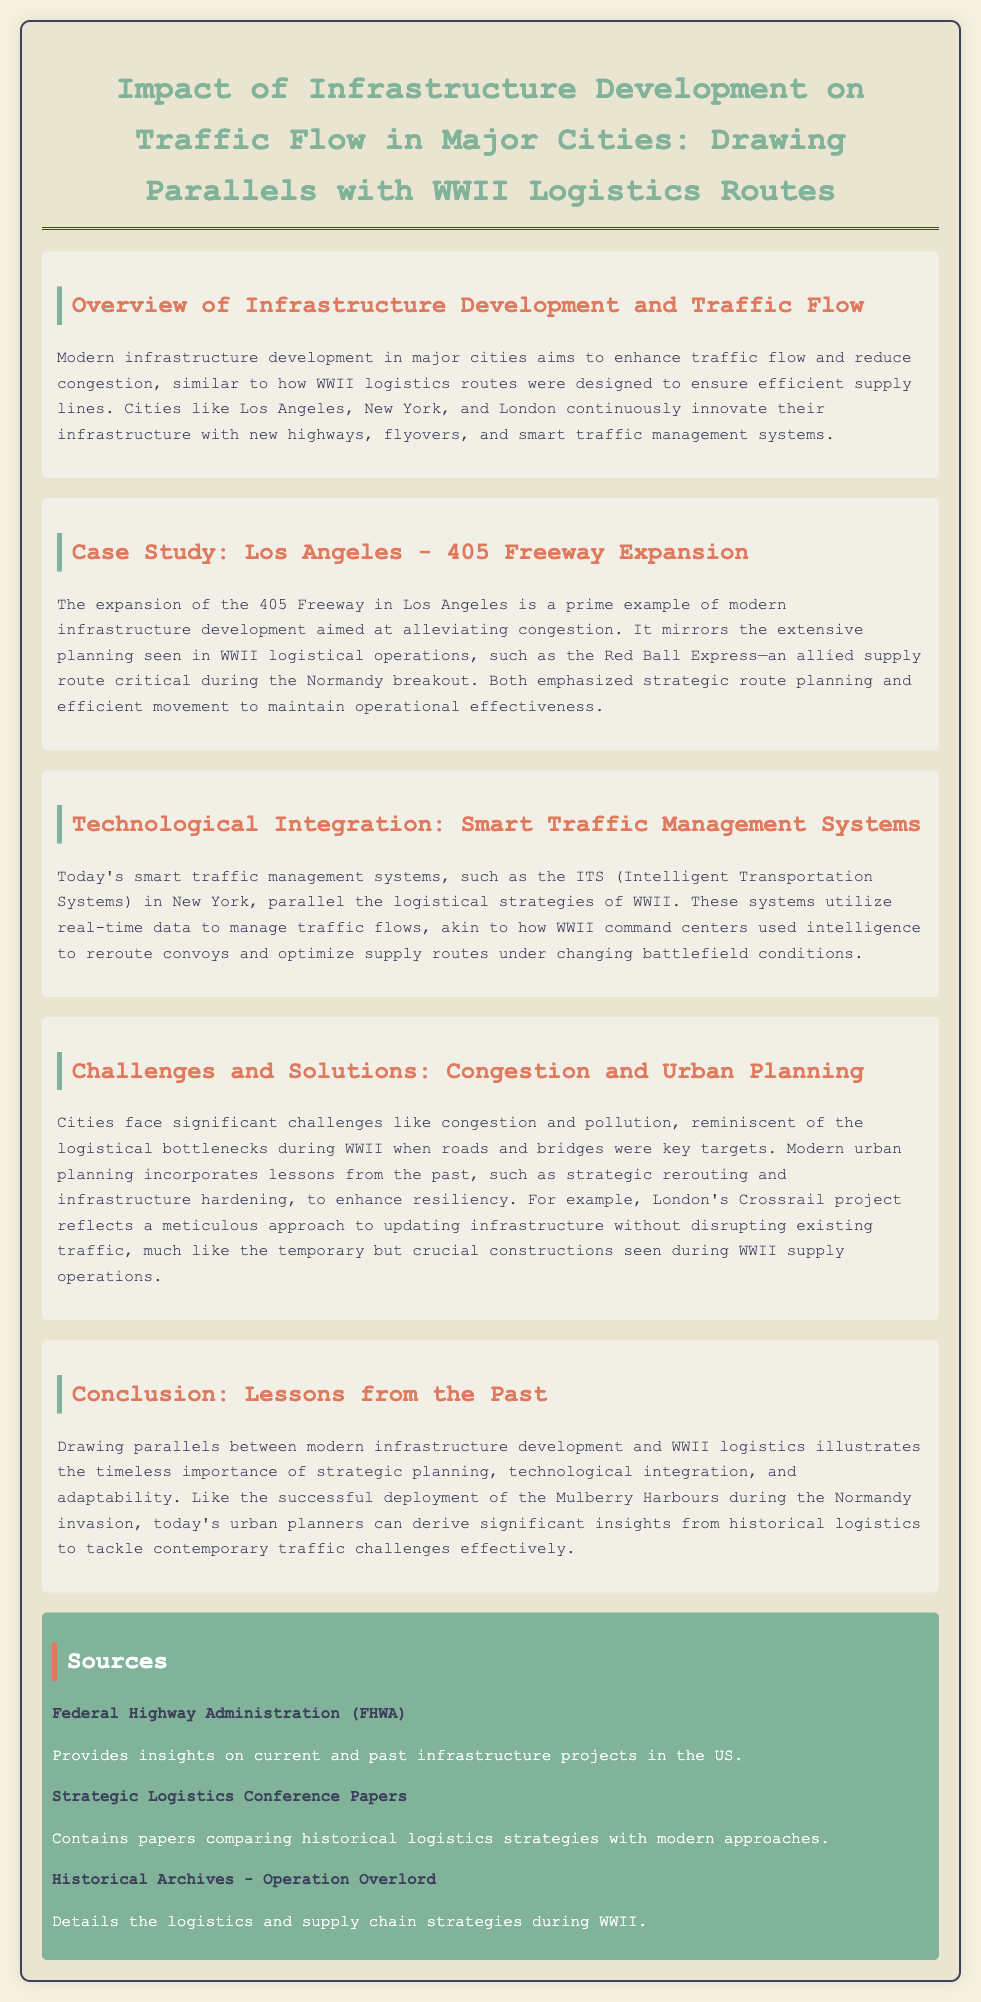What is the title of the report? The title of the report is presented at the top of the document, summarizing its focus on infrastructure and traffic flow.
Answer: Impact of Infrastructure Development on Traffic Flow in Major Cities: Drawing Parallels with WWII Logistics Routes Which city is highlighted for freeway expansion? The specific case study in the document points out a significant infrastructure project that took place in this city.
Answer: Los Angeles What does ITS stand for in the context of modern traffic systems? The abbreviation is provided in the section discussing smart traffic management systems, detailing its full form.
Answer: Intelligent Transportation Systems What historical operation is compared to the 405 Freeway expansion? The document mentions a specific logistic operation that serves as a parallel to infrastructure strategies implemented during WWII.
Answer: Red Ball Express What major construction project is referenced in London? An example is provided to illustrate modern urban planning efforts and its comparison to historical logistics strategies during WWII.
Answer: Crossrail Which aspect of traffic management involves real-time data? The report discusses certain modern technologies that allow for optimizing traffic flow, similarly to historical logistics adaptations.
Answer: Smart Traffic Management Systems What are key challenges faced by modern cities mentioned in the report? The challenges detailed concern urban traffic dynamics, reflecting issues from both modern times and historical operations.
Answer: Congestion and pollution What type of planning is emphasized for both modern infrastructure and WWII logistics? The document highlights the importance of an approach that involves careful consideration and strategic foresight in both contexts.
Answer: Strategic planning 